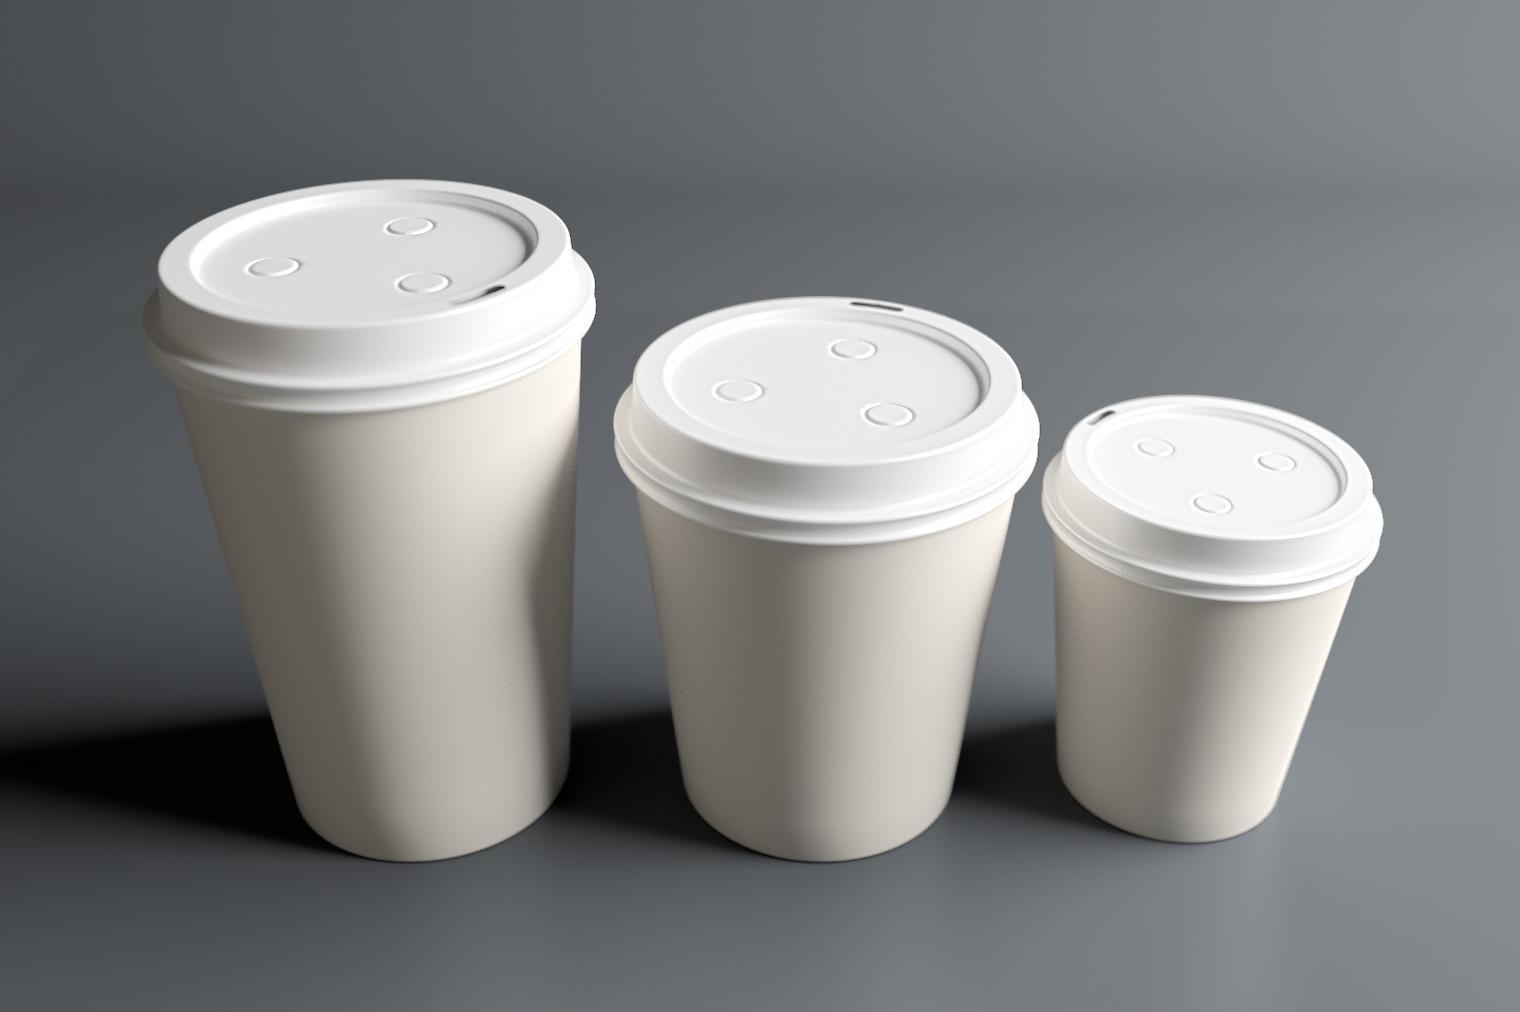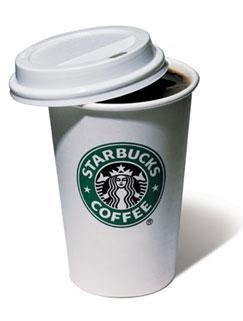The first image is the image on the left, the second image is the image on the right. Analyze the images presented: Is the assertion "There are 3 white coffee cups and saucers" valid? Answer yes or no. No. The first image is the image on the left, the second image is the image on the right. Considering the images on both sides, is "The right image has three empty white coffee cups." valid? Answer yes or no. No. 